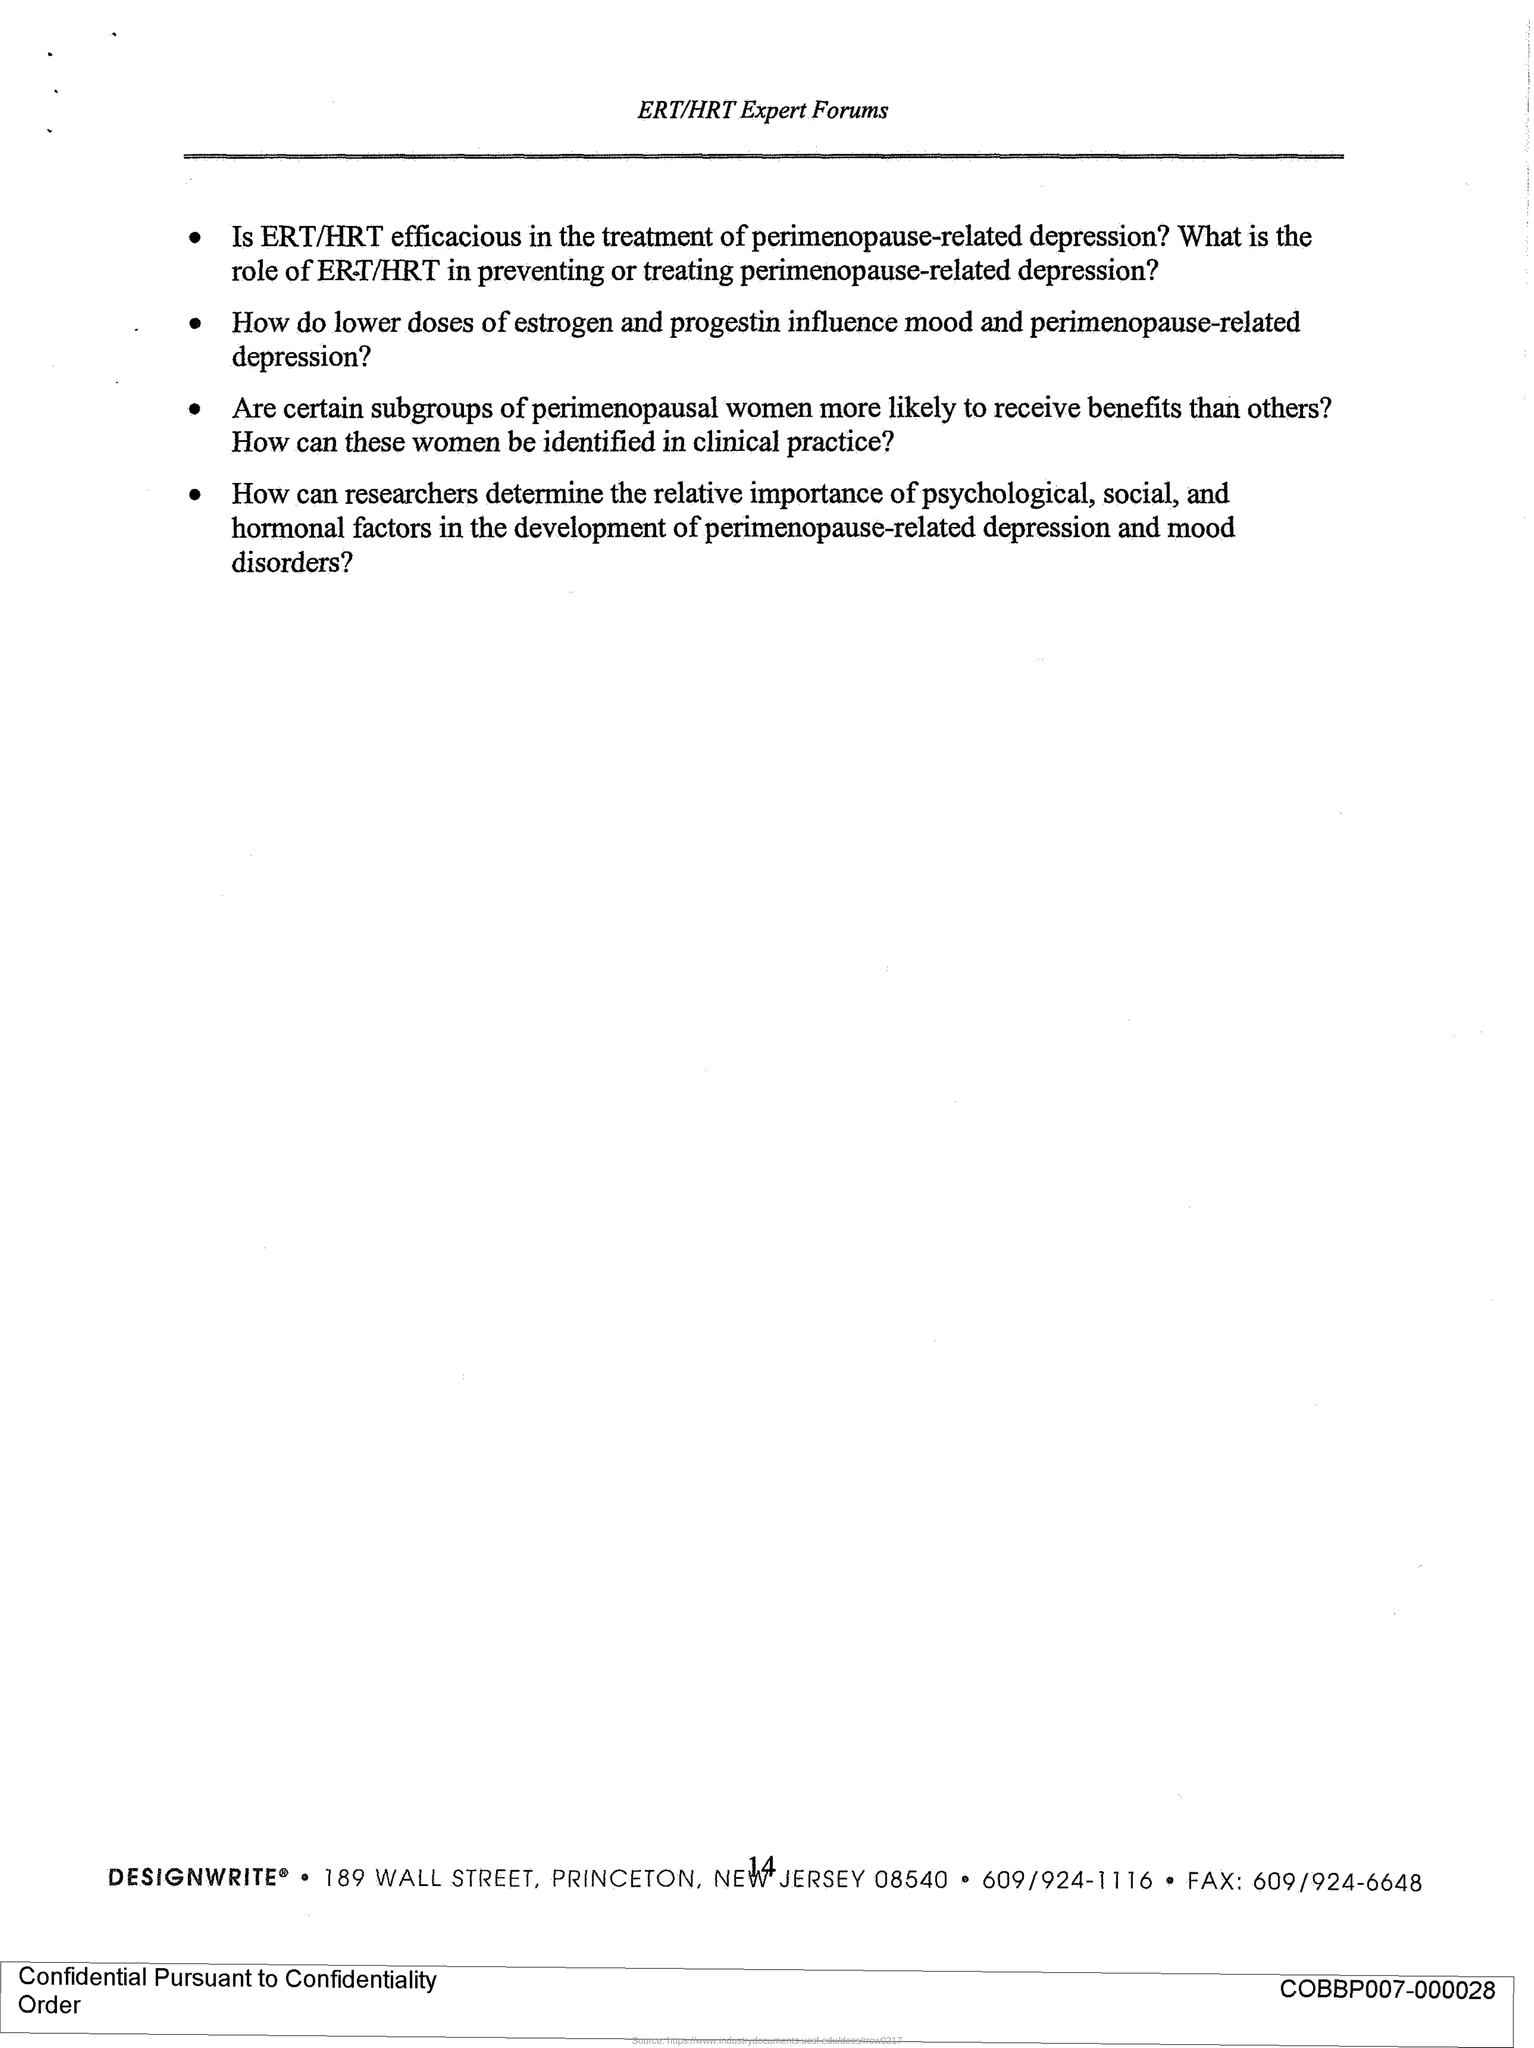What is the Page Number?
Offer a terse response. 14. What is the Fax number?
Ensure brevity in your answer.  609/924-6648. 